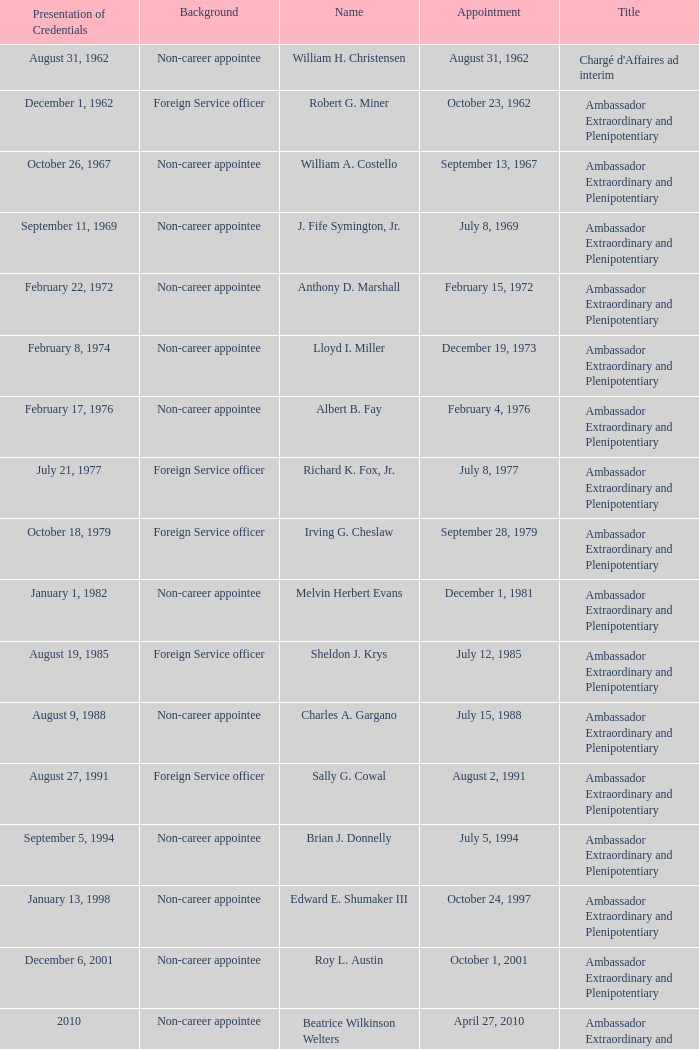Who was appointed on October 24, 1997? Edward E. Shumaker III. 